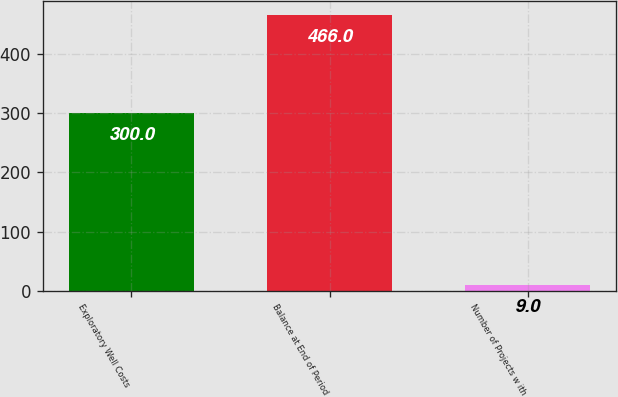Convert chart. <chart><loc_0><loc_0><loc_500><loc_500><bar_chart><fcel>Exploratory Well Costs<fcel>Balance at End of Period<fcel>Number of Projects w ith<nl><fcel>300<fcel>466<fcel>9<nl></chart> 